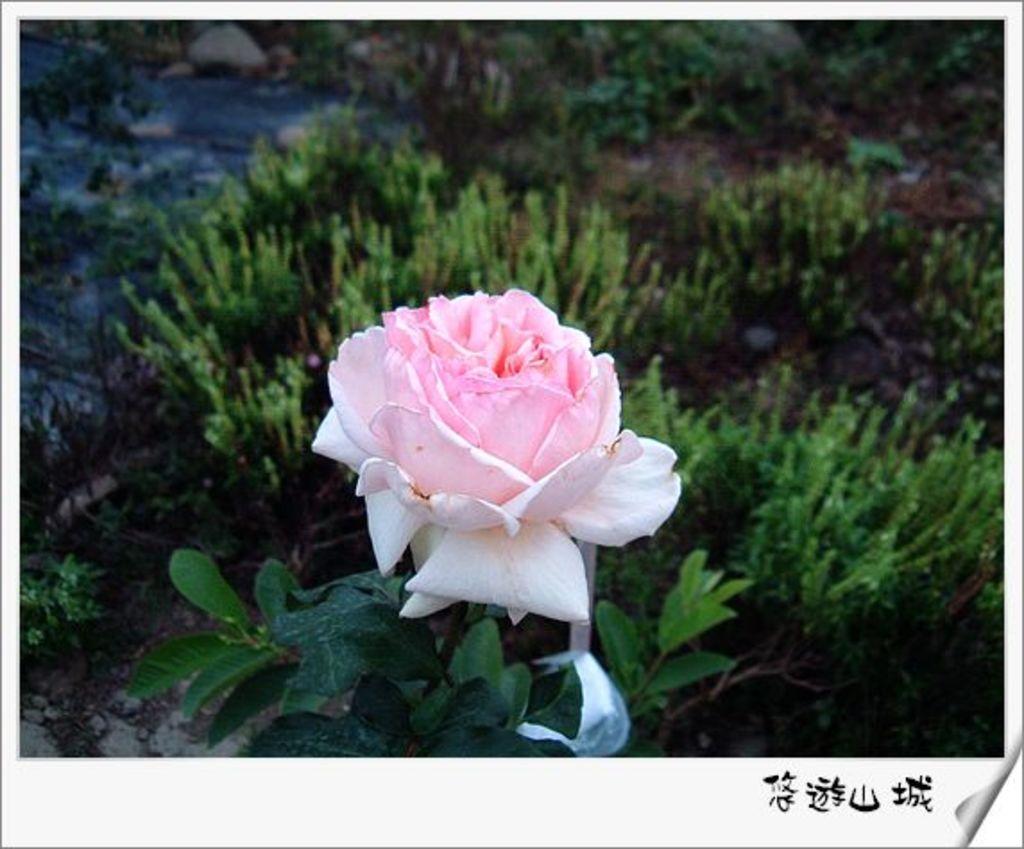Could you give a brief overview of what you see in this image? This is an edited image with the borders. In the center there is a pink color rose and we can see the green leaves and plants. In the bottom right corner there is a watermark on the image. 